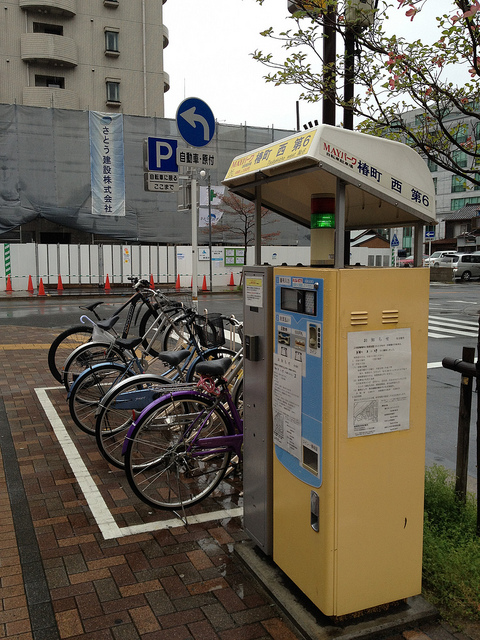Please extract the text content from this image. P 6 